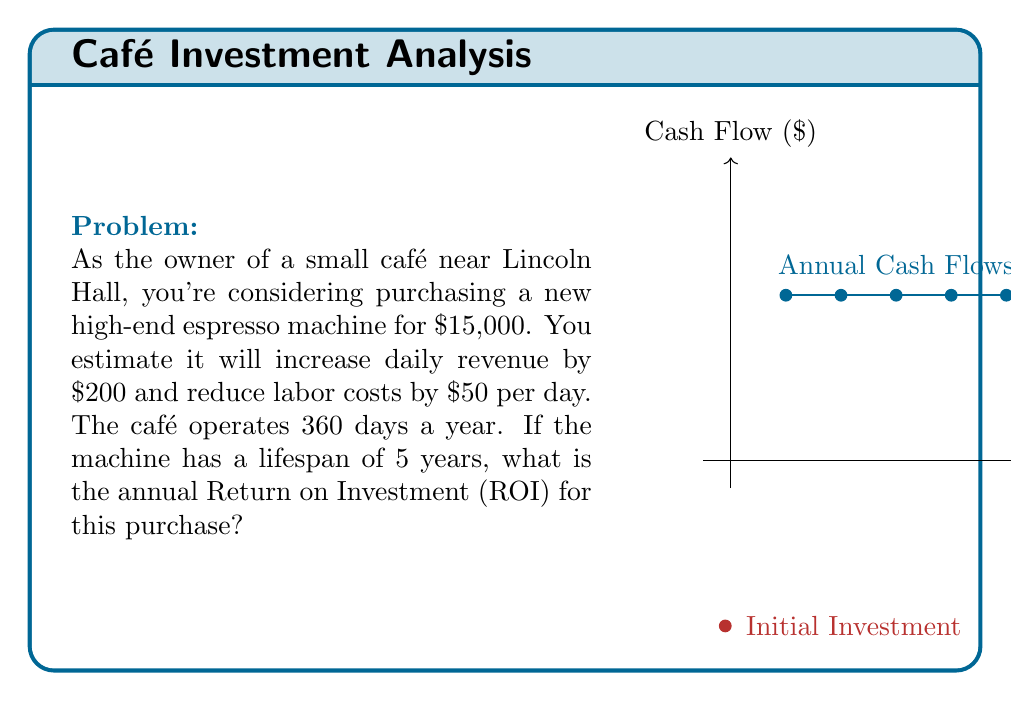Solve this math problem. To calculate the annual Return on Investment (ROI), we need to follow these steps:

1. Calculate the annual cash inflow:
   Daily revenue increase: $200
   Daily labor cost reduction: $50
   Total daily benefit: $200 + $50 = $250
   Annual benefit: $250 × 360 days = $90,000

2. Calculate the total cash inflow over 5 years:
   $90,000 × 5 years = $450,000

3. Calculate the net profit over 5 years:
   Net profit = Total cash inflow - Initial investment
   $450,000 - $15,000 = $435,000

4. Calculate the average annual profit:
   $435,000 ÷ 5 years = $87,000

5. Calculate the ROI:
   ROI = (Average Annual Profit ÷ Initial Investment) × 100%
   
   $$ROI = \frac{\$87,000}{\$15,000} \times 100\% = 5.8 \times 100\% = 580\%$$

Therefore, the annual Return on Investment for purchasing the new espresso machine is 580%.
Answer: 580% 